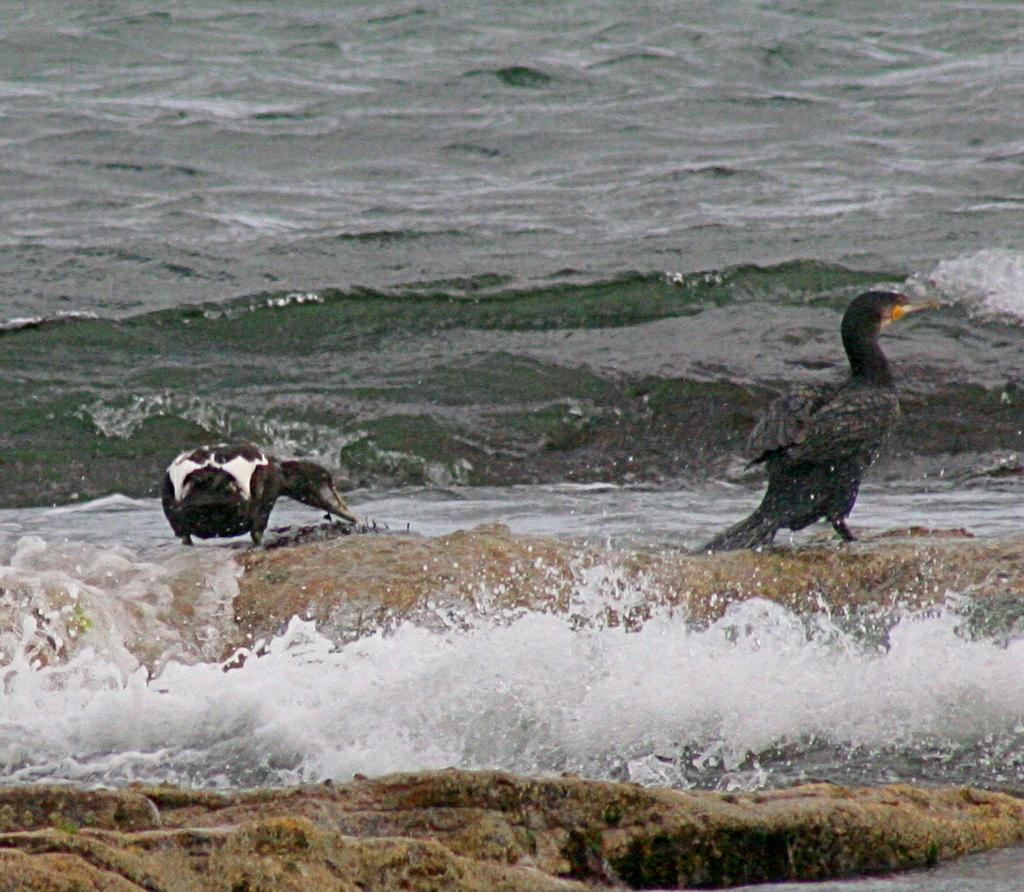What type of birds are in the image? There are two double crested cormorants in the image. Where are the cormorants located? The cormorants are on a rock. What can be seen in the background of the image? In the background, there is water visible. What type of joke does the goose tell in the image? There is no goose present in the image, so it cannot tell any jokes. 